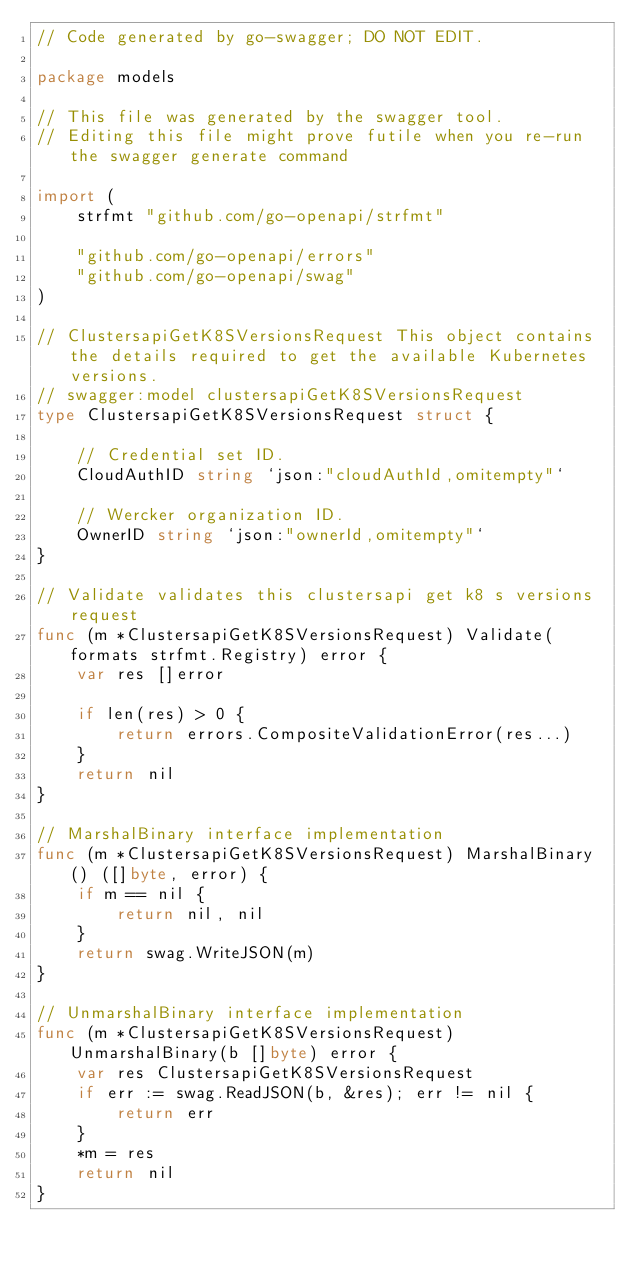<code> <loc_0><loc_0><loc_500><loc_500><_Go_>// Code generated by go-swagger; DO NOT EDIT.

package models

// This file was generated by the swagger tool.
// Editing this file might prove futile when you re-run the swagger generate command

import (
	strfmt "github.com/go-openapi/strfmt"

	"github.com/go-openapi/errors"
	"github.com/go-openapi/swag"
)

// ClustersapiGetK8SVersionsRequest This object contains the details required to get the available Kubernetes versions.
// swagger:model clustersapiGetK8SVersionsRequest
type ClustersapiGetK8SVersionsRequest struct {

	// Credential set ID.
	CloudAuthID string `json:"cloudAuthId,omitempty"`

	// Wercker organization ID.
	OwnerID string `json:"ownerId,omitempty"`
}

// Validate validates this clustersapi get k8 s versions request
func (m *ClustersapiGetK8SVersionsRequest) Validate(formats strfmt.Registry) error {
	var res []error

	if len(res) > 0 {
		return errors.CompositeValidationError(res...)
	}
	return nil
}

// MarshalBinary interface implementation
func (m *ClustersapiGetK8SVersionsRequest) MarshalBinary() ([]byte, error) {
	if m == nil {
		return nil, nil
	}
	return swag.WriteJSON(m)
}

// UnmarshalBinary interface implementation
func (m *ClustersapiGetK8SVersionsRequest) UnmarshalBinary(b []byte) error {
	var res ClustersapiGetK8SVersionsRequest
	if err := swag.ReadJSON(b, &res); err != nil {
		return err
	}
	*m = res
	return nil
}
</code> 